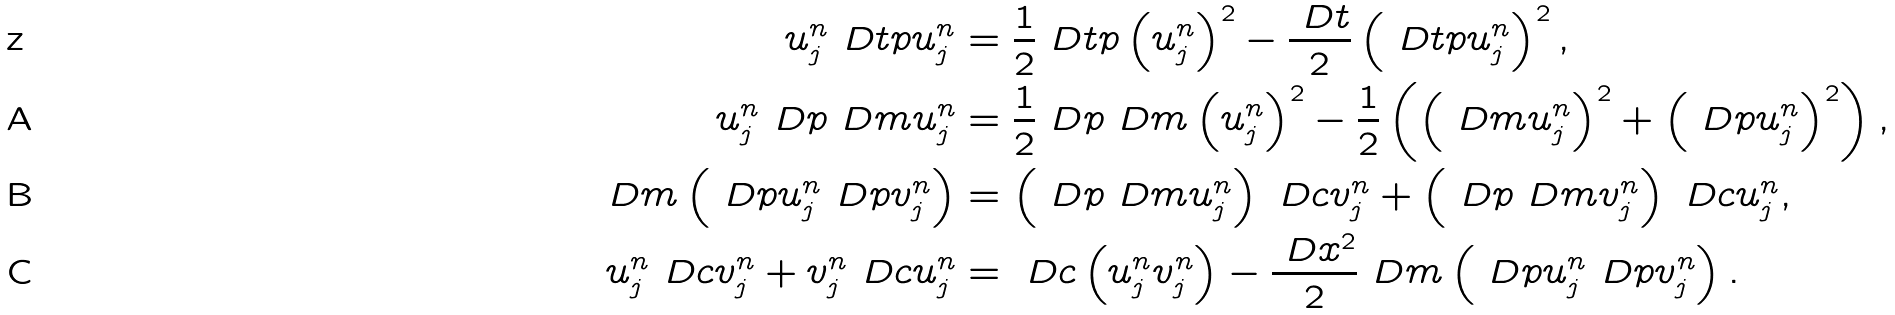Convert formula to latex. <formula><loc_0><loc_0><loc_500><loc_500>u ^ { n } _ { j } \ D t p u ^ { n } _ { j } & = \frac { 1 } { 2 } \ D t p \left ( u ^ { n } _ { j } \right ) ^ { 2 } - \frac { \ D t } 2 \left ( \ D t p u ^ { n } _ { j } \right ) ^ { 2 } , \\ u ^ { n } _ { j } \ D p \ D m u ^ { n } _ { j } & = \frac { 1 } { 2 } \ D p \ D m \left ( u ^ { n } _ { j } \right ) ^ { 2 } - \frac { 1 } { 2 } \left ( \left ( \ D m u ^ { n } _ { j } \right ) ^ { 2 } + \left ( \ D p u ^ { n } _ { j } \right ) ^ { 2 } \right ) , \\ \ D m \left ( \ D p u ^ { n } _ { j } \ D p v ^ { n } _ { j } \right ) & = \left ( \ D p \ D m u ^ { n } _ { j } \right ) \ D c v ^ { n } _ { j } + \left ( \ D p \ D m v ^ { n } _ { j } \right ) \ D c u ^ { n } _ { j } , \\ u ^ { n } _ { j } \ D c v ^ { n } _ { j } + v ^ { n } _ { j } \ D c u ^ { n } _ { j } & = \ D c \left ( u ^ { n } _ { j } v ^ { n } _ { j } \right ) - \frac { \ D x ^ { 2 } } { 2 } \ D m \left ( \ D p u ^ { n } _ { j } \ D p v ^ { n } _ { j } \right ) .</formula> 